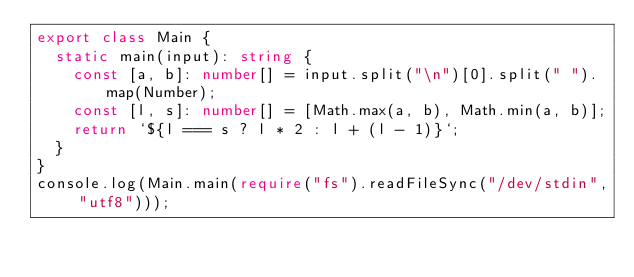<code> <loc_0><loc_0><loc_500><loc_500><_TypeScript_>export class Main {
  static main(input): string {
    const [a, b]: number[] = input.split("\n")[0].split(" ").map(Number);
    const [l, s]: number[] = [Math.max(a, b), Math.min(a, b)];
    return `${l === s ? l * 2 : l + (l - 1)}`;
  }
}
console.log(Main.main(require("fs").readFileSync("/dev/stdin", "utf8")));</code> 